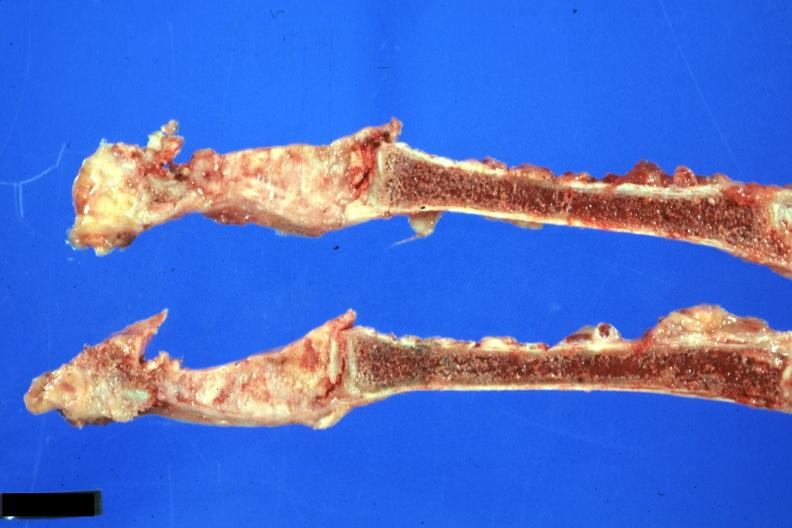s joints present?
Answer the question using a single word or phrase. Yes 